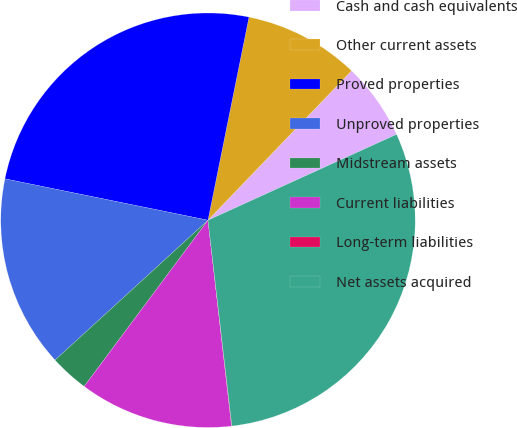<chart> <loc_0><loc_0><loc_500><loc_500><pie_chart><fcel>Cash and cash equivalents<fcel>Other current assets<fcel>Proved properties<fcel>Unproved properties<fcel>Midstream assets<fcel>Current liabilities<fcel>Long-term liabilities<fcel>Net assets acquired<nl><fcel>6.02%<fcel>9.01%<fcel>24.97%<fcel>14.99%<fcel>3.02%<fcel>12.0%<fcel>0.03%<fcel>29.96%<nl></chart> 